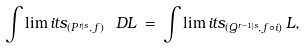<formula> <loc_0><loc_0><loc_500><loc_500>\int \lim i t s _ { ( P ^ { r | s } , \, f ) } \, \ D L \, = \, \int \lim i t s _ { ( Q ^ { r - 1 | s } , \, f \circ i ) } \, L ,</formula> 